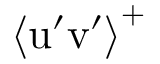<formula> <loc_0><loc_0><loc_500><loc_500>\left \langle u ^ { \prime } v ^ { \prime } \right \rangle ^ { + }</formula> 